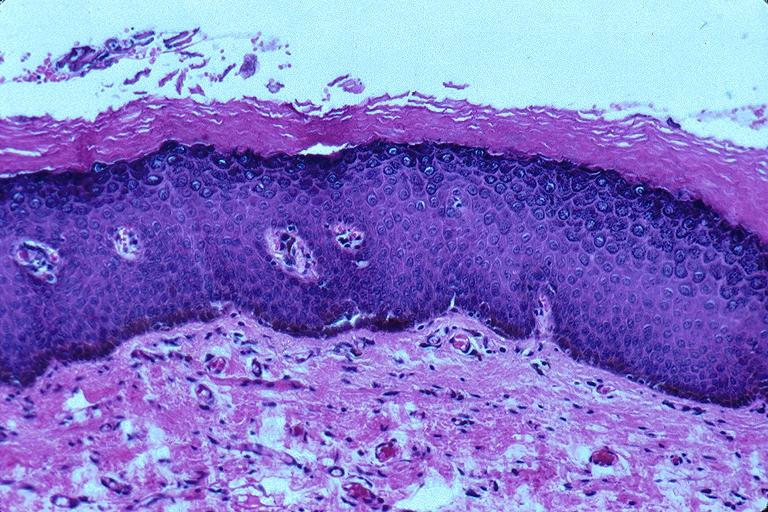does this image show epithelial hyperplasia and hyperkeratosis?
Answer the question using a single word or phrase. Yes 